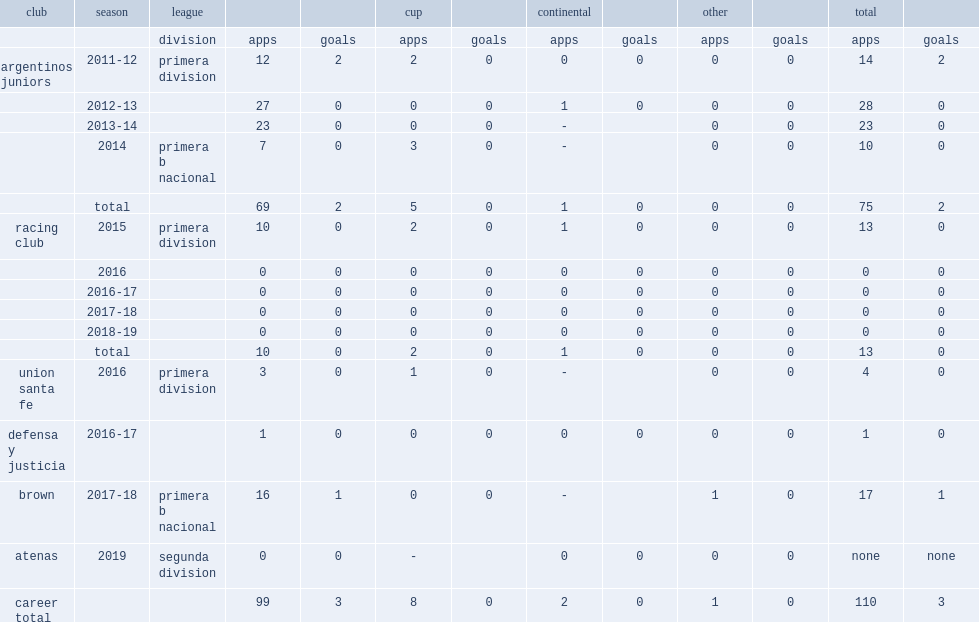Which club did naguel play for in 2019? Atenas. Could you help me parse every detail presented in this table? {'header': ['club', 'season', 'league', '', '', 'cup', '', 'continental', '', 'other', '', 'total', ''], 'rows': [['', '', 'division', 'apps', 'goals', 'apps', 'goals', 'apps', 'goals', 'apps', 'goals', 'apps', 'goals'], ['argentinos juniors', '2011-12', 'primera division', '12', '2', '2', '0', '0', '0', '0', '0', '14', '2'], ['', '2012-13', '', '27', '0', '0', '0', '1', '0', '0', '0', '28', '0'], ['', '2013-14', '', '23', '0', '0', '0', '-', '', '0', '0', '23', '0'], ['', '2014', 'primera b nacional', '7', '0', '3', '0', '-', '', '0', '0', '10', '0'], ['', 'total', '', '69', '2', '5', '0', '1', '0', '0', '0', '75', '2'], ['racing club', '2015', 'primera division', '10', '0', '2', '0', '1', '0', '0', '0', '13', '0'], ['', '2016', '', '0', '0', '0', '0', '0', '0', '0', '0', '0', '0'], ['', '2016-17', '', '0', '0', '0', '0', '0', '0', '0', '0', '0', '0'], ['', '2017-18', '', '0', '0', '0', '0', '0', '0', '0', '0', '0', '0'], ['', '2018-19', '', '0', '0', '0', '0', '0', '0', '0', '0', '0', '0'], ['', 'total', '', '10', '0', '2', '0', '1', '0', '0', '0', '13', '0'], ['union santa fe', '2016', 'primera division', '3', '0', '1', '0', '-', '', '0', '0', '4', '0'], ['defensa y justicia', '2016-17', '', '1', '0', '0', '0', '0', '0', '0', '0', '1', '0'], ['brown', '2017-18', 'primera b nacional', '16', '1', '0', '0', '-', '', '1', '0', '17', '1'], ['atenas', '2019', 'segunda division', '0', '0', '-', '', '0', '0', '0', '0', 'none', 'none'], ['career total', '', '', '99', '3', '8', '0', '2', '0', '1', '0', '110', '3']]} 